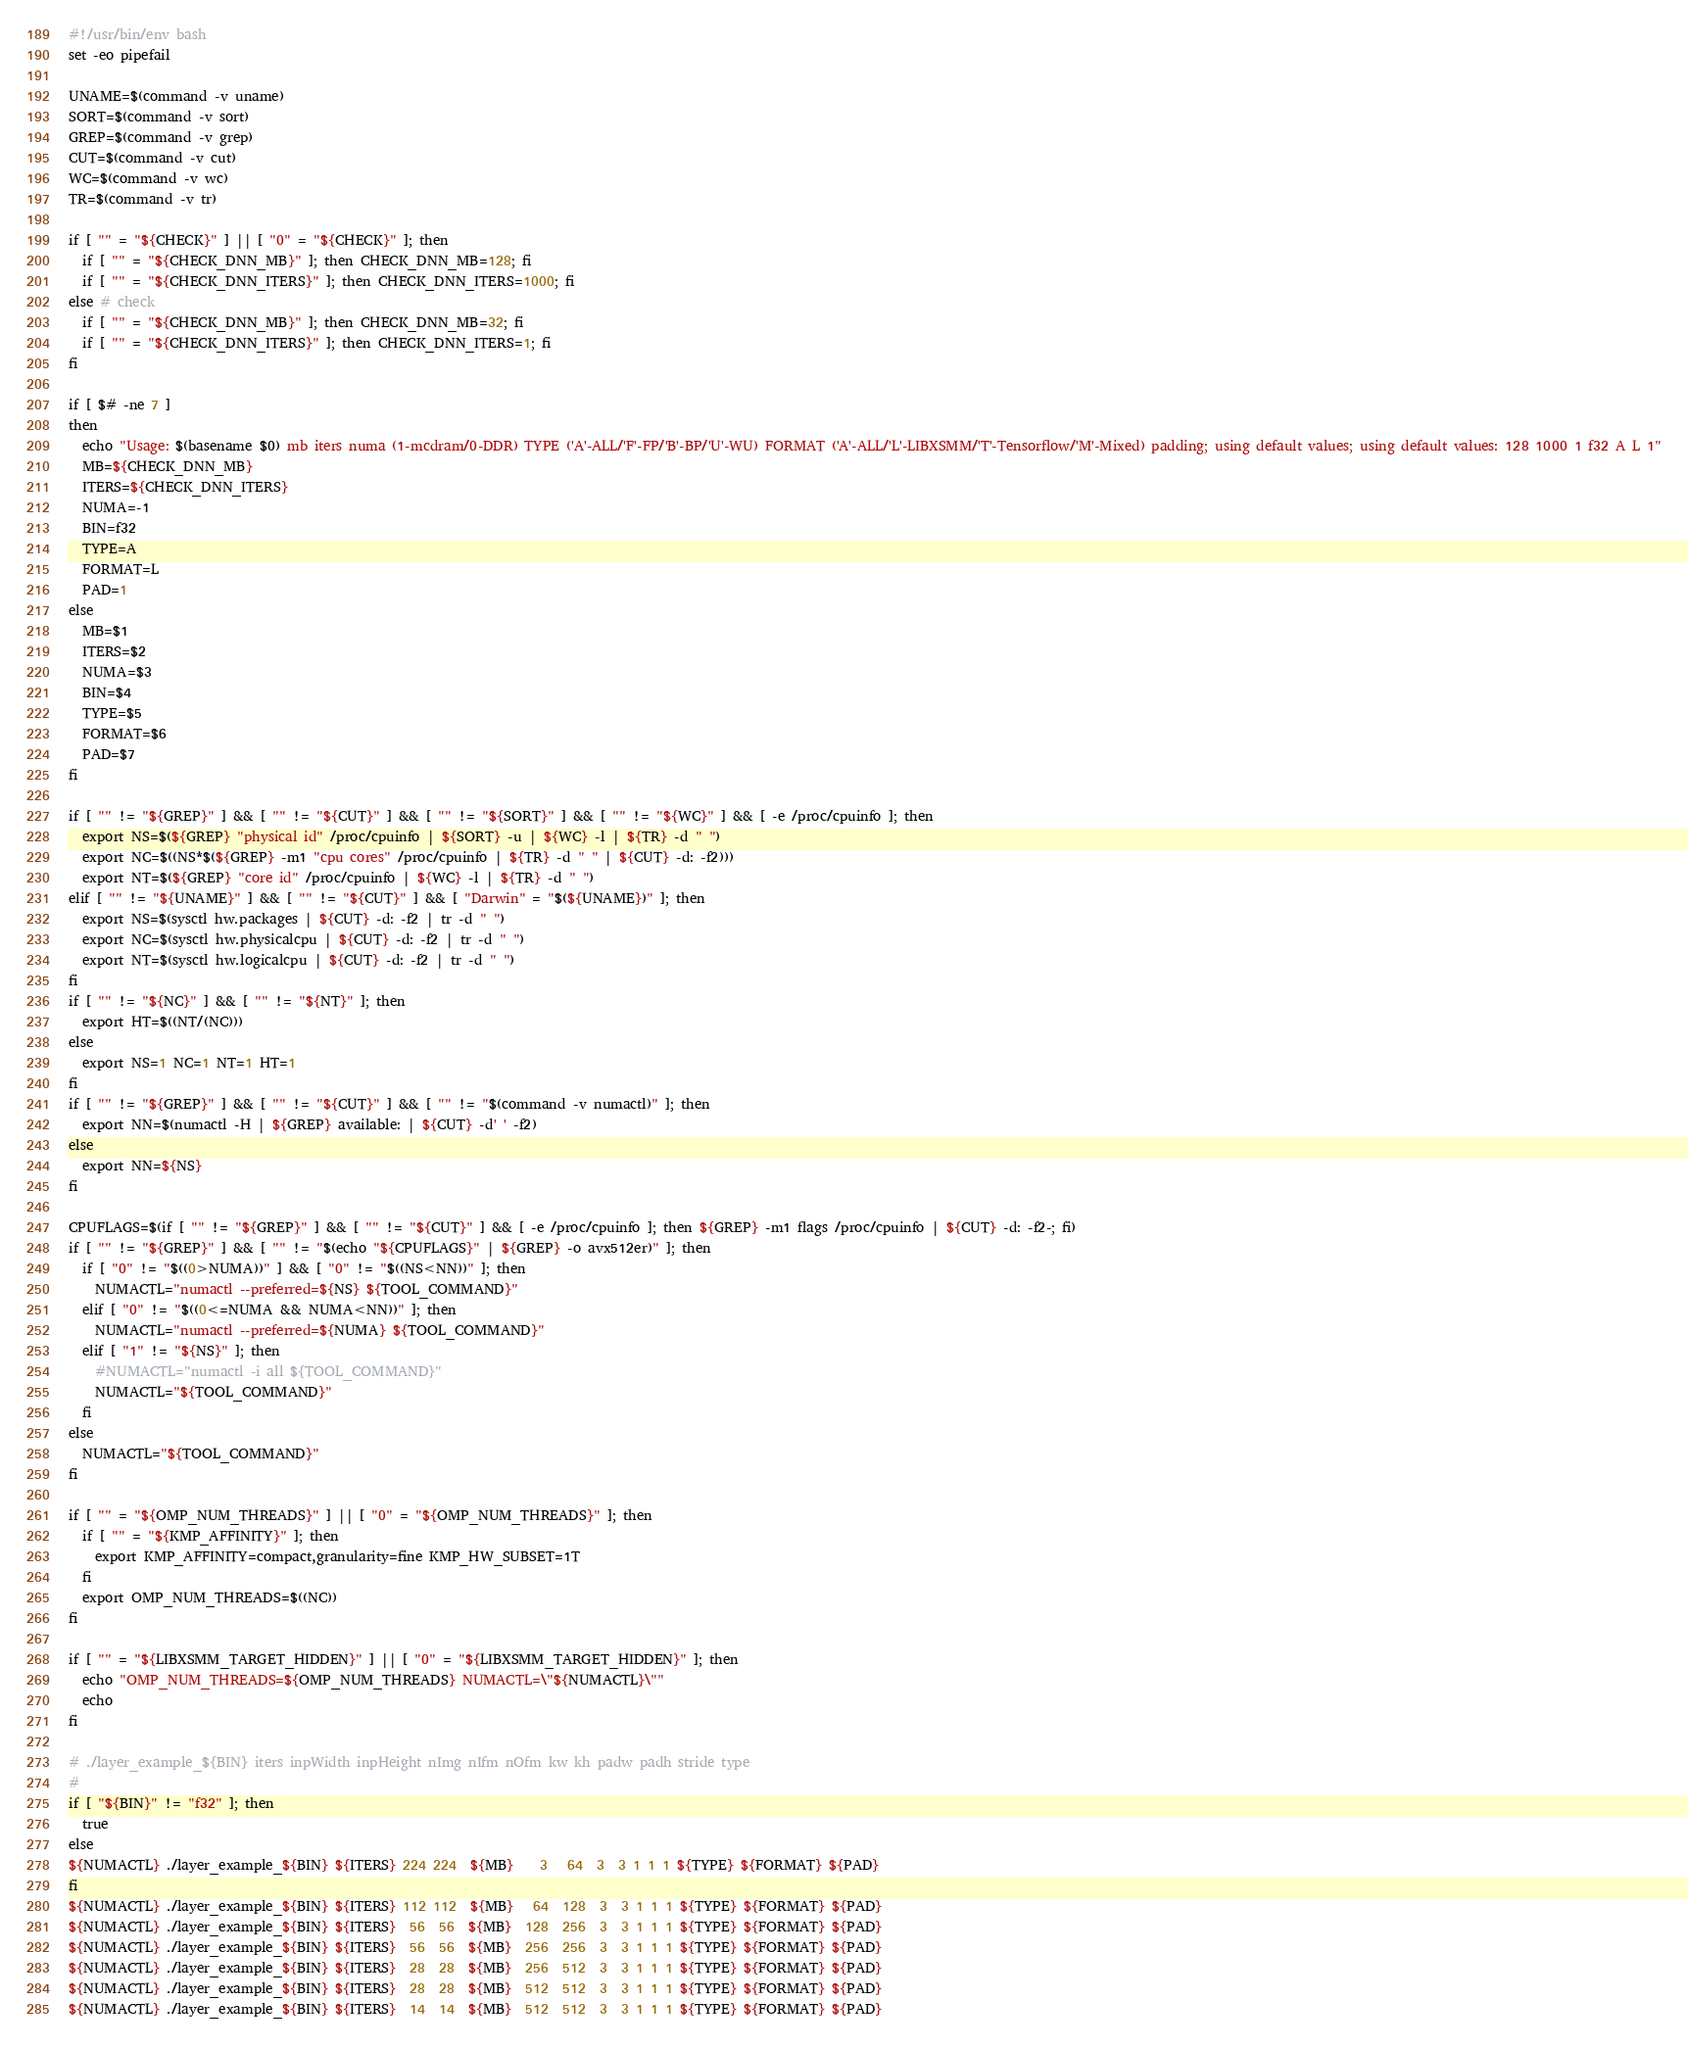Convert code to text. <code><loc_0><loc_0><loc_500><loc_500><_Bash_>#!/usr/bin/env bash
set -eo pipefail

UNAME=$(command -v uname)
SORT=$(command -v sort)
GREP=$(command -v grep)
CUT=$(command -v cut)
WC=$(command -v wc)
TR=$(command -v tr)

if [ "" = "${CHECK}" ] || [ "0" = "${CHECK}" ]; then
  if [ "" = "${CHECK_DNN_MB}" ]; then CHECK_DNN_MB=128; fi
  if [ "" = "${CHECK_DNN_ITERS}" ]; then CHECK_DNN_ITERS=1000; fi
else # check
  if [ "" = "${CHECK_DNN_MB}" ]; then CHECK_DNN_MB=32; fi
  if [ "" = "${CHECK_DNN_ITERS}" ]; then CHECK_DNN_ITERS=1; fi
fi

if [ $# -ne 7 ]
then
  echo "Usage: $(basename $0) mb iters numa (1-mcdram/0-DDR) TYPE ('A'-ALL/'F'-FP/'B'-BP/'U'-WU) FORMAT ('A'-ALL/'L'-LIBXSMM/'T'-Tensorflow/'M'-Mixed) padding; using default values; using default values: 128 1000 1 f32 A L 1"
  MB=${CHECK_DNN_MB}
  ITERS=${CHECK_DNN_ITERS}
  NUMA=-1
  BIN=f32
  TYPE=A
  FORMAT=L
  PAD=1
else
  MB=$1
  ITERS=$2
  NUMA=$3
  BIN=$4
  TYPE=$5
  FORMAT=$6
  PAD=$7
fi

if [ "" != "${GREP}" ] && [ "" != "${CUT}" ] && [ "" != "${SORT}" ] && [ "" != "${WC}" ] && [ -e /proc/cpuinfo ]; then
  export NS=$(${GREP} "physical id" /proc/cpuinfo | ${SORT} -u | ${WC} -l | ${TR} -d " ")
  export NC=$((NS*$(${GREP} -m1 "cpu cores" /proc/cpuinfo | ${TR} -d " " | ${CUT} -d: -f2)))
  export NT=$(${GREP} "core id" /proc/cpuinfo | ${WC} -l | ${TR} -d " ")
elif [ "" != "${UNAME}" ] && [ "" != "${CUT}" ] && [ "Darwin" = "$(${UNAME})" ]; then
  export NS=$(sysctl hw.packages | ${CUT} -d: -f2 | tr -d " ")
  export NC=$(sysctl hw.physicalcpu | ${CUT} -d: -f2 | tr -d " ")
  export NT=$(sysctl hw.logicalcpu | ${CUT} -d: -f2 | tr -d " ")
fi
if [ "" != "${NC}" ] && [ "" != "${NT}" ]; then
  export HT=$((NT/(NC)))
else
  export NS=1 NC=1 NT=1 HT=1
fi
if [ "" != "${GREP}" ] && [ "" != "${CUT}" ] && [ "" != "$(command -v numactl)" ]; then
  export NN=$(numactl -H | ${GREP} available: | ${CUT} -d' ' -f2)
else
  export NN=${NS}
fi

CPUFLAGS=$(if [ "" != "${GREP}" ] && [ "" != "${CUT}" ] && [ -e /proc/cpuinfo ]; then ${GREP} -m1 flags /proc/cpuinfo | ${CUT} -d: -f2-; fi)
if [ "" != "${GREP}" ] && [ "" != "$(echo "${CPUFLAGS}" | ${GREP} -o avx512er)" ]; then
  if [ "0" != "$((0>NUMA))" ] && [ "0" != "$((NS<NN))" ]; then
    NUMACTL="numactl --preferred=${NS} ${TOOL_COMMAND}"
  elif [ "0" != "$((0<=NUMA && NUMA<NN))" ]; then
    NUMACTL="numactl --preferred=${NUMA} ${TOOL_COMMAND}"
  elif [ "1" != "${NS}" ]; then
    #NUMACTL="numactl -i all ${TOOL_COMMAND}"
    NUMACTL="${TOOL_COMMAND}"
  fi
else
  NUMACTL="${TOOL_COMMAND}"
fi

if [ "" = "${OMP_NUM_THREADS}" ] || [ "0" = "${OMP_NUM_THREADS}" ]; then
  if [ "" = "${KMP_AFFINITY}" ]; then
    export KMP_AFFINITY=compact,granularity=fine KMP_HW_SUBSET=1T
  fi
  export OMP_NUM_THREADS=$((NC))
fi

if [ "" = "${LIBXSMM_TARGET_HIDDEN}" ] || [ "0" = "${LIBXSMM_TARGET_HIDDEN}" ]; then
  echo "OMP_NUM_THREADS=${OMP_NUM_THREADS} NUMACTL=\"${NUMACTL}\""
  echo
fi

# ./layer_example_${BIN} iters inpWidth inpHeight nImg nIfm nOfm kw kh padw padh stride type
#
if [ "${BIN}" != "f32" ]; then
  true
else
${NUMACTL} ./layer_example_${BIN} ${ITERS} 224 224  ${MB}    3   64  3  3 1 1 1 ${TYPE} ${FORMAT} ${PAD}
fi
${NUMACTL} ./layer_example_${BIN} ${ITERS} 112 112  ${MB}   64  128  3  3 1 1 1 ${TYPE} ${FORMAT} ${PAD}
${NUMACTL} ./layer_example_${BIN} ${ITERS}  56  56  ${MB}  128  256  3  3 1 1 1 ${TYPE} ${FORMAT} ${PAD}
${NUMACTL} ./layer_example_${BIN} ${ITERS}  56  56  ${MB}  256  256  3  3 1 1 1 ${TYPE} ${FORMAT} ${PAD}
${NUMACTL} ./layer_example_${BIN} ${ITERS}  28  28  ${MB}  256  512  3  3 1 1 1 ${TYPE} ${FORMAT} ${PAD}
${NUMACTL} ./layer_example_${BIN} ${ITERS}  28  28  ${MB}  512  512  3  3 1 1 1 ${TYPE} ${FORMAT} ${PAD}
${NUMACTL} ./layer_example_${BIN} ${ITERS}  14  14  ${MB}  512  512  3  3 1 1 1 ${TYPE} ${FORMAT} ${PAD}

</code> 